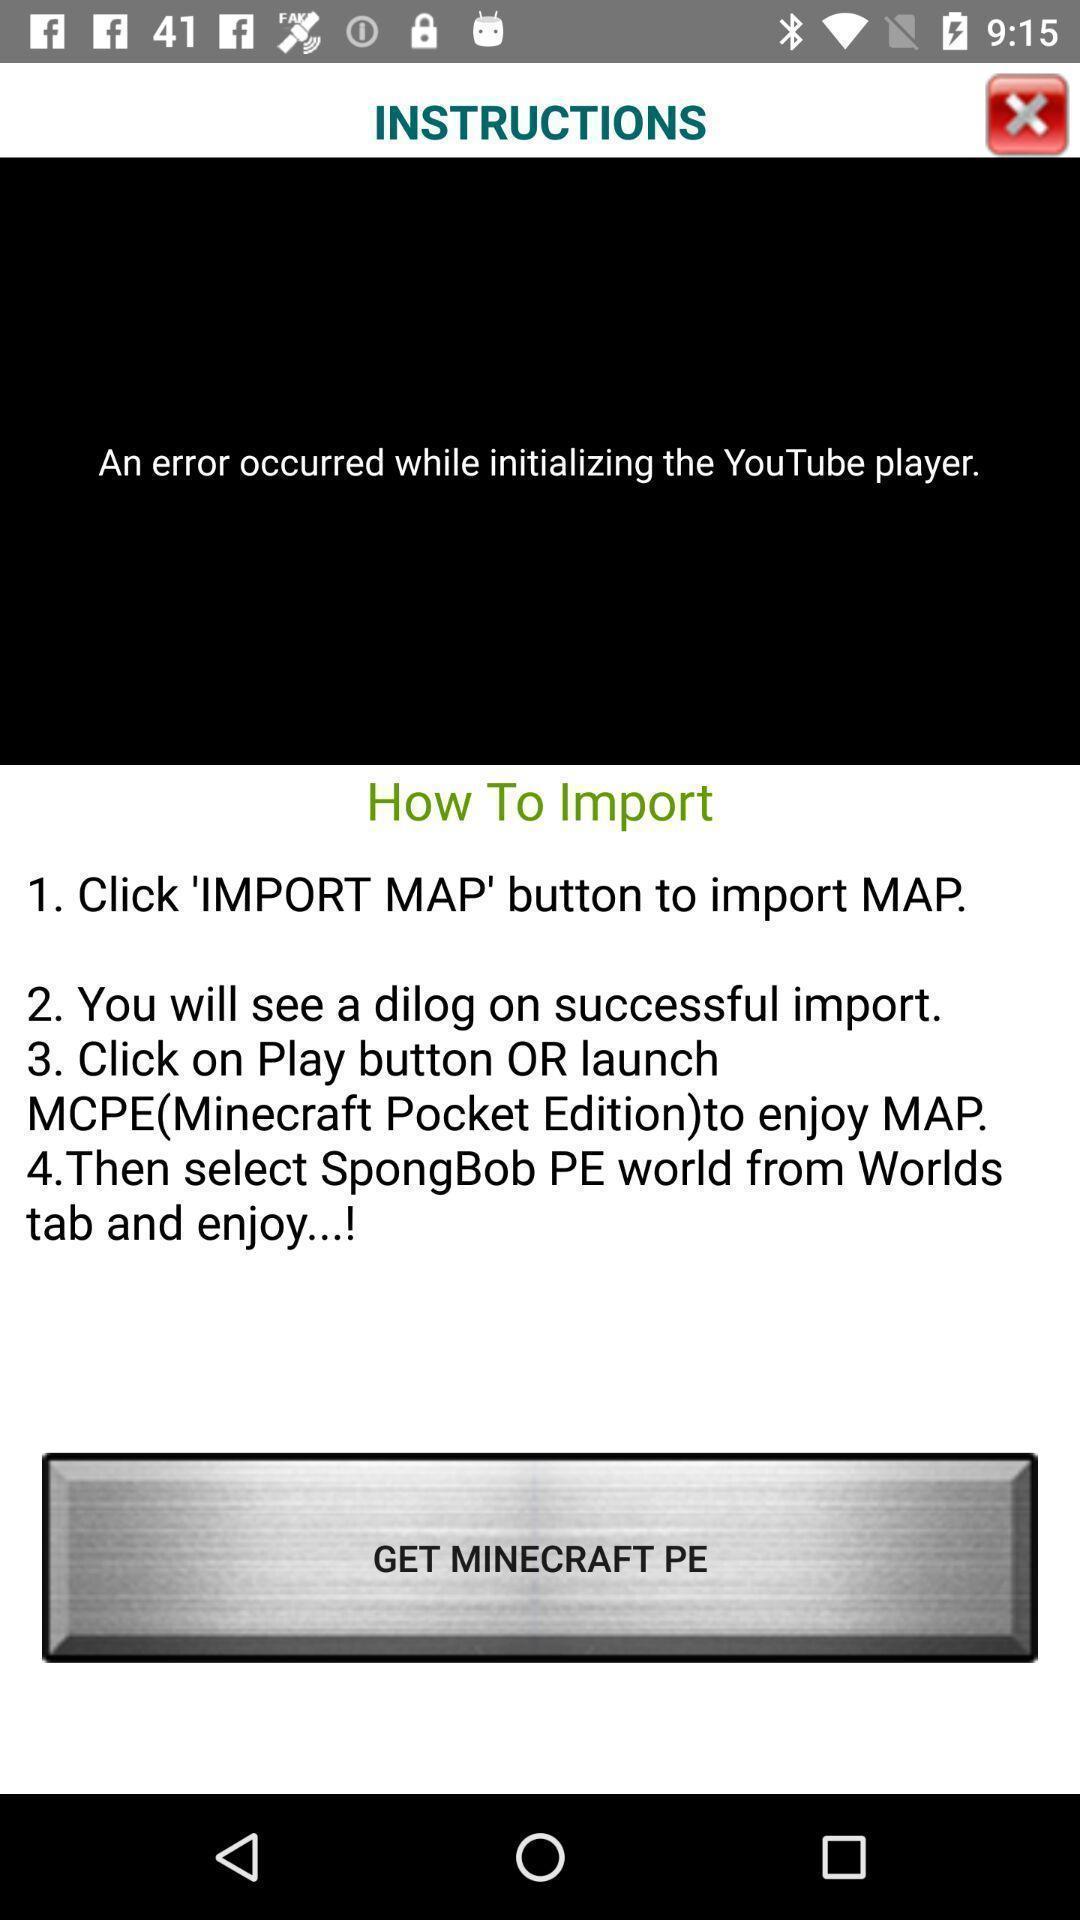Describe this image in words. Screen displaying instructions details. 